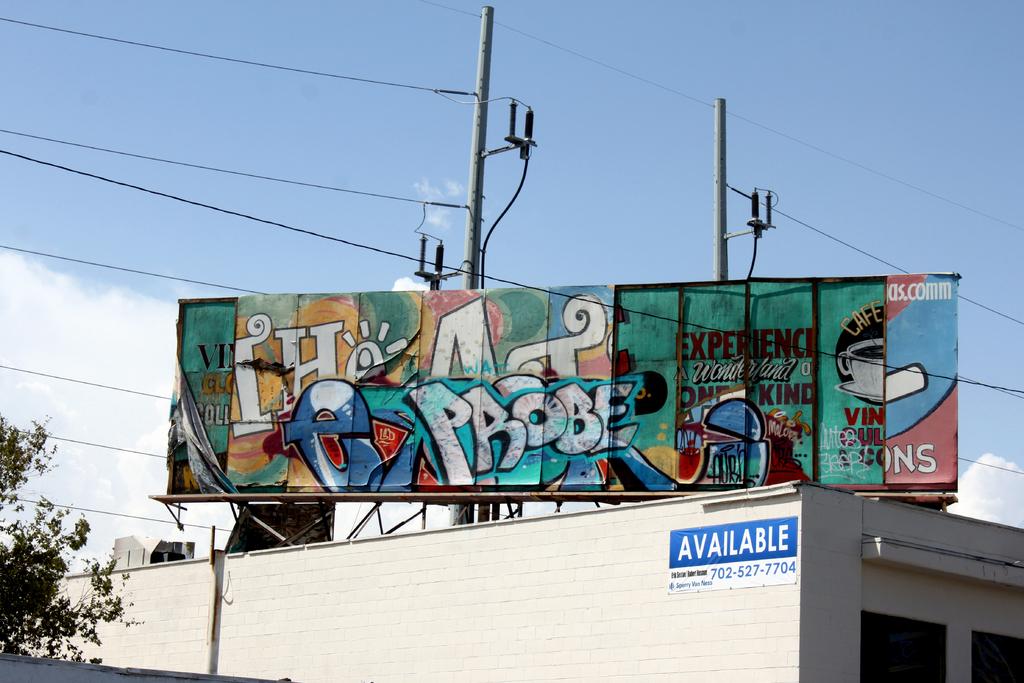What does the number above the phone number say?
Provide a succinct answer. Available. 